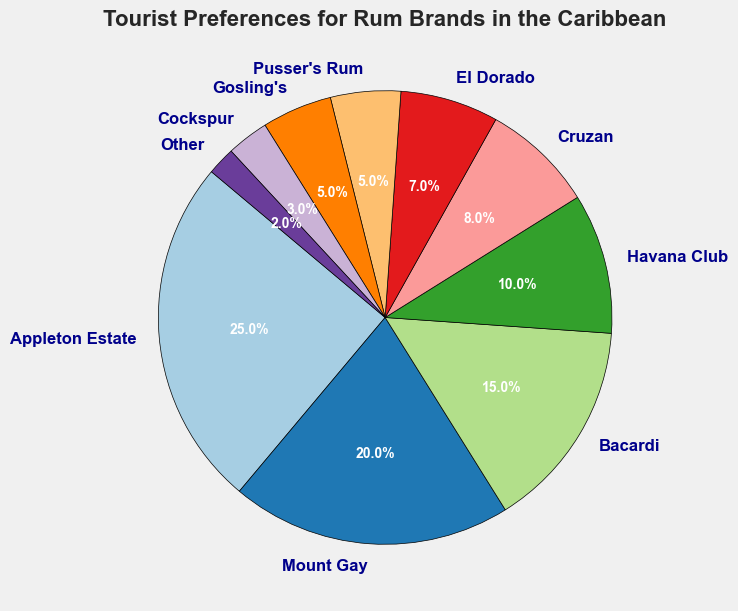Which rum brand has the highest preference among tourists? To determine which rum brand has the highest preference, look for the largest segment in the pie chart. This segment represents the greatest percentage.
Answer: Appleton Estate Which two rum brands have an equal preference percentage? Check for two segments in the pie chart that have the same percentage value label. Both segments will represent the same proportion of the pie.
Answer: Pusser's Rum and Gosling's What's the combined preference percentage for Bacardi and Havana Club? Bacardi has a 15% preference, and Havana Club has a 10% preference. Add these two percentages together: 15% + 10% = 25%.
Answer: 25% Is the preference percentage for Mount Gay greater than that for Cruzan? Find the segments representing Mount Gay and Cruzan and compare their percentages. Mount Gay has 20% and Cruzan has 8%, so 20% is greater than 8%.
Answer: Yes What is the preference percentage difference between Appleton Estate and El Dorado? Identify the percentages for both brands: Appleton Estate (25%) and El Dorado (7%). Subtract the smaller percentage from the larger one: 25% - 7% = 18%.
Answer: 18% Which rum brands have a combined preference percentage less than 10%? Look for segments with preference percentages adding up to less than 10%. Cockspur (3%) and Other (2%) combine for 5%, which is less than 10%.
Answer: Cockspur and Other What percentage more does Appleton Estate have over Bacardi? Appleton Estate has 25%, and Bacardi has 15%. Subtract Bacardi's percentage from Appleton Estate's: 25% - 15% = 10%. Then express it as a percentage of Bacardi's value: (10 / 15) * 100 ≈ 66.7%.
Answer: 66.7% Is the total preference percentage for Mount Gay and Appleton Estate more than 40%? Mount Gay has 20% and Appleton Estate has 25%. Add these percentages: 20% + 25% = 45%. Since 45% is greater than 40%, the total is more.
Answer: Yes What is the average preference percentage of the five least popular brands? The least popular five brands are El Dorado (7%), Pusser's Rum (5%), Gosling's (5%), Cockspur (3%), and Other (2%). Sum these percentages: 7% + 5% + 5% + 3% + 2% = 22%. Divide by the number of brands: 22% / 5 = 4.4%.
Answer: 4.4% What is the median preference percentage among all the brands? List the percentages in numerical order: 2%, 3%, 5%, 5%, 7%, 8%, 10%, 15%, 20%, 25%. Since there are 10 brands, the median is the average of the 5th and 6th values: (7% + 8%) / 2 = 7.5%.
Answer: 7.5% 